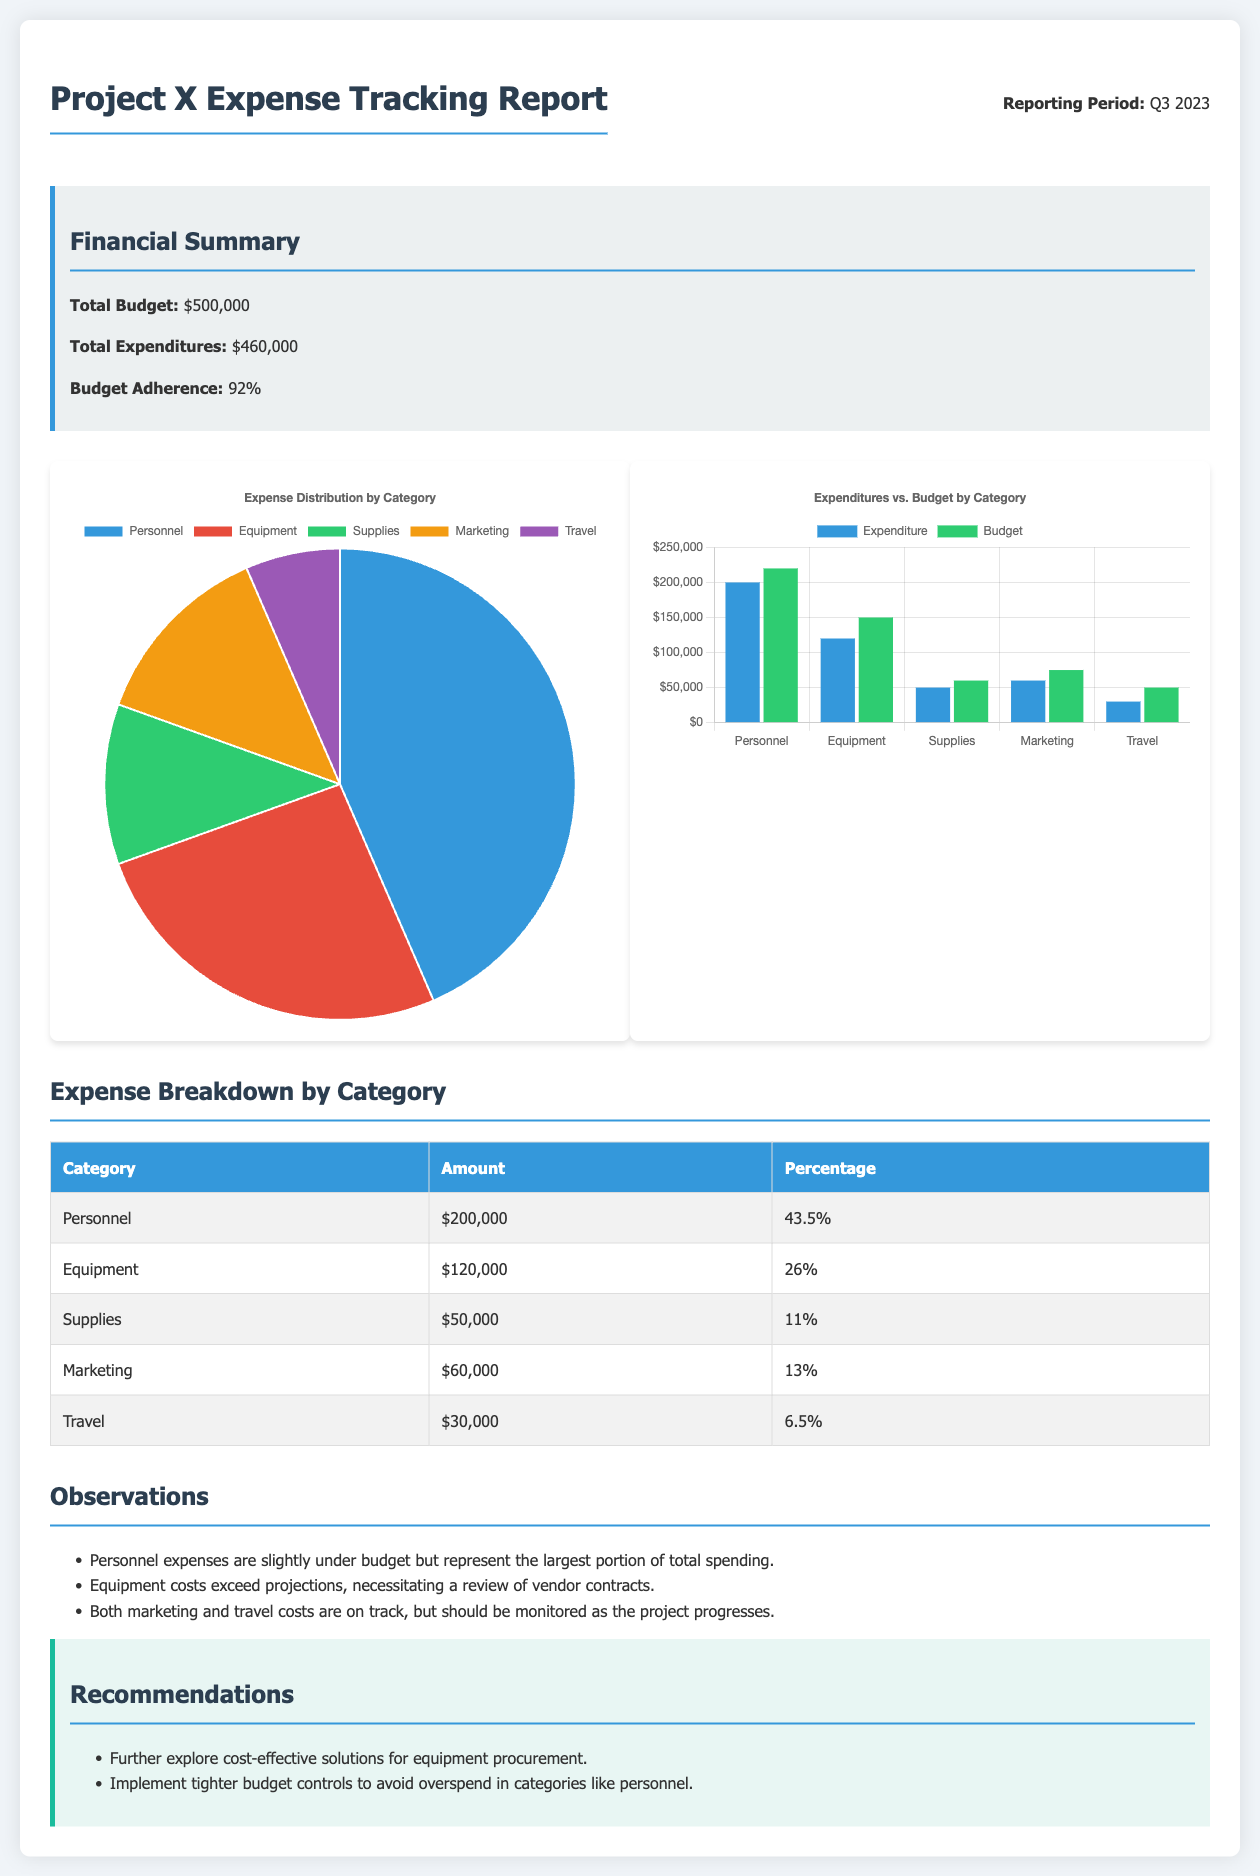What is the total budget for Project X? The total budget is outlined in the financial summary section of the report.
Answer: $500,000 What is the total expenditure reported? The total expenditures are specified in the financial summary section of the report.
Answer: $460,000 What percentage does budget adherence represent? Budget adherence is stated as part of the financial summary in the document.
Answer: 92% Which category has the highest expenditure? The category with the highest expenditure is determined from the expense breakdown table in the document.
Answer: Personnel What is the amount spent on Marketing? The amount for Marketing is found in the expense breakdown table of the report.
Answer: $60,000 How much did the project spend on Travel? The amount spent on Travel is provided in the expense breakdown table within the document.
Answer: $30,000 Which category shows a need for a review of vendor contracts? This requires reasoning based on the observations made about the expenditures in the document.
Answer: Equipment What recommendation is given regarding equipment procurement? This is based on the recommendations section in the document, addressing cost efficiency for equipment.
Answer: Explore cost-effective solutions What is the percentage spent on Supplies? The percentage for Supplies is found directly in the expense breakdown table presented in the document.
Answer: 11% 